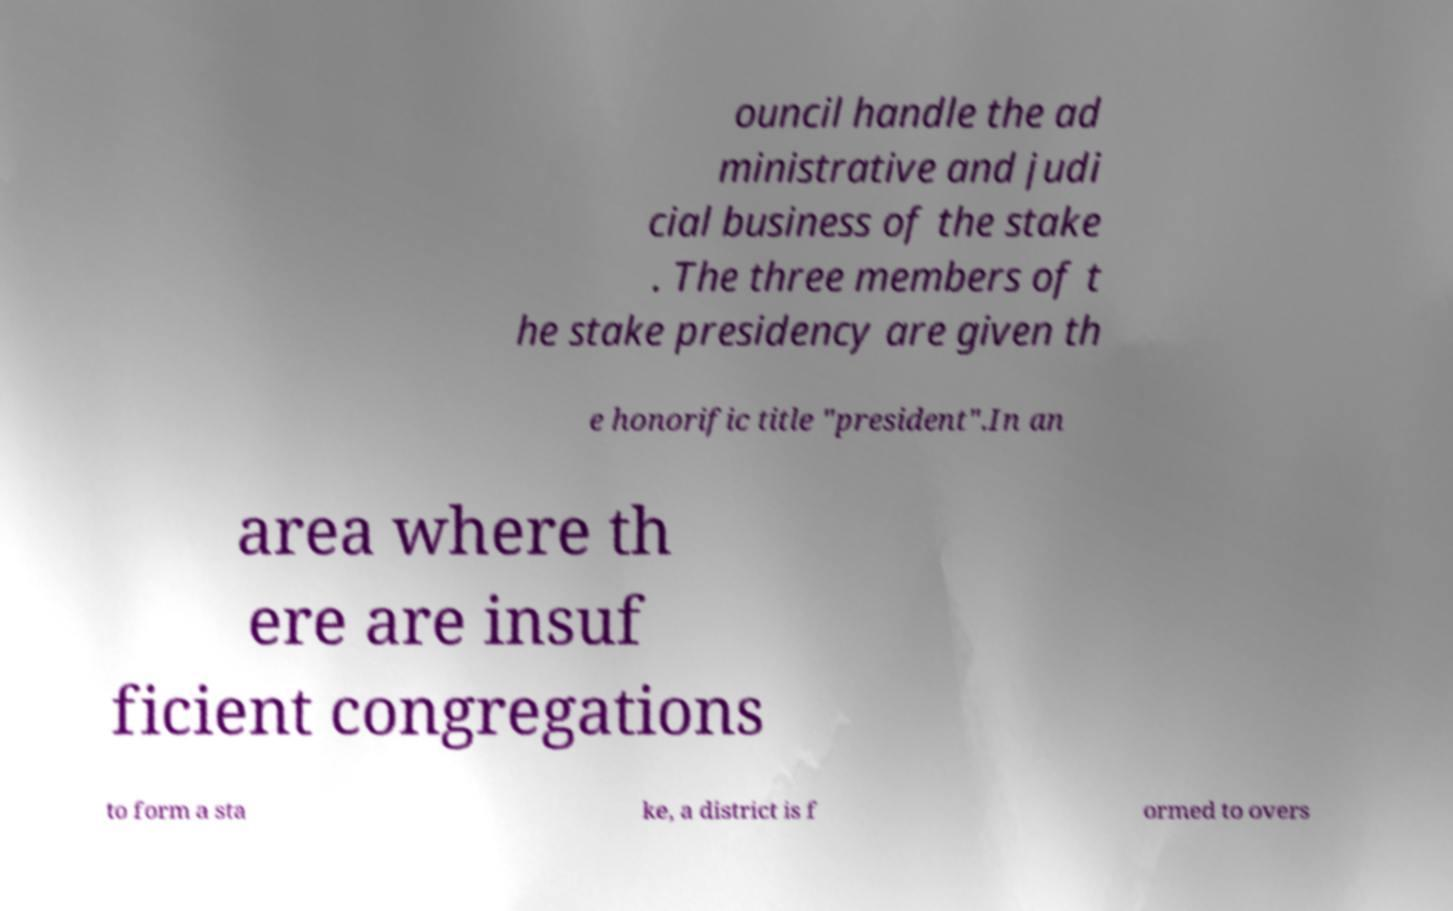Can you accurately transcribe the text from the provided image for me? ouncil handle the ad ministrative and judi cial business of the stake . The three members of t he stake presidency are given th e honorific title "president".In an area where th ere are insuf ficient congregations to form a sta ke, a district is f ormed to overs 